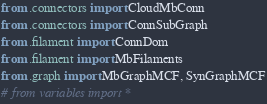<code> <loc_0><loc_0><loc_500><loc_500><_Python_>from .connectors import CloudMbConn
from .connectors import ConnSubGraph
from .filament import ConnDom
from .filament import MbFilaments
from .graph import MbGraphMCF, SynGraphMCF
# from variables import *

</code> 